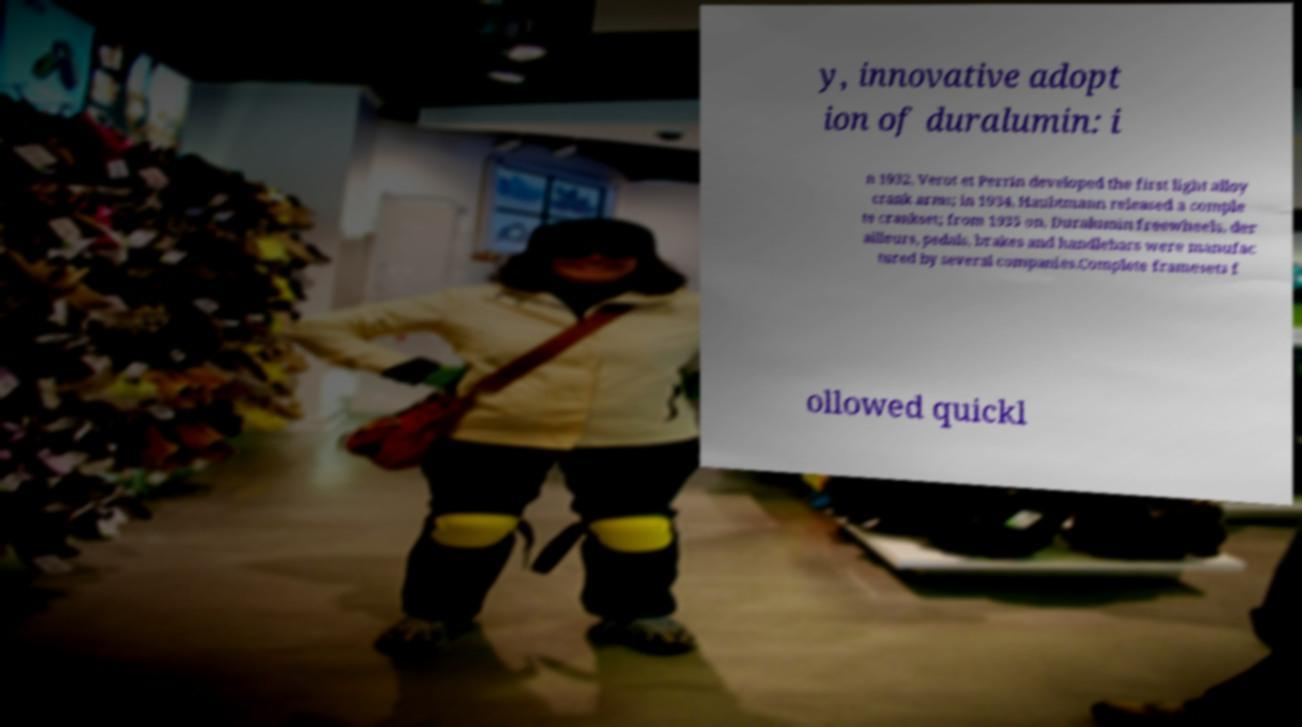Please read and relay the text visible in this image. What does it say? y, innovative adopt ion of duralumin: i n 1932, Verot et Perrin developed the first light alloy crank arms; in 1934, Haubtmann released a comple te crankset; from 1935 on, Duralumin freewheels, der ailleurs, pedals, brakes and handlebars were manufac tured by several companies.Complete framesets f ollowed quickl 